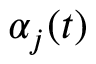<formula> <loc_0><loc_0><loc_500><loc_500>{ \alpha _ { j } ( t ) }</formula> 